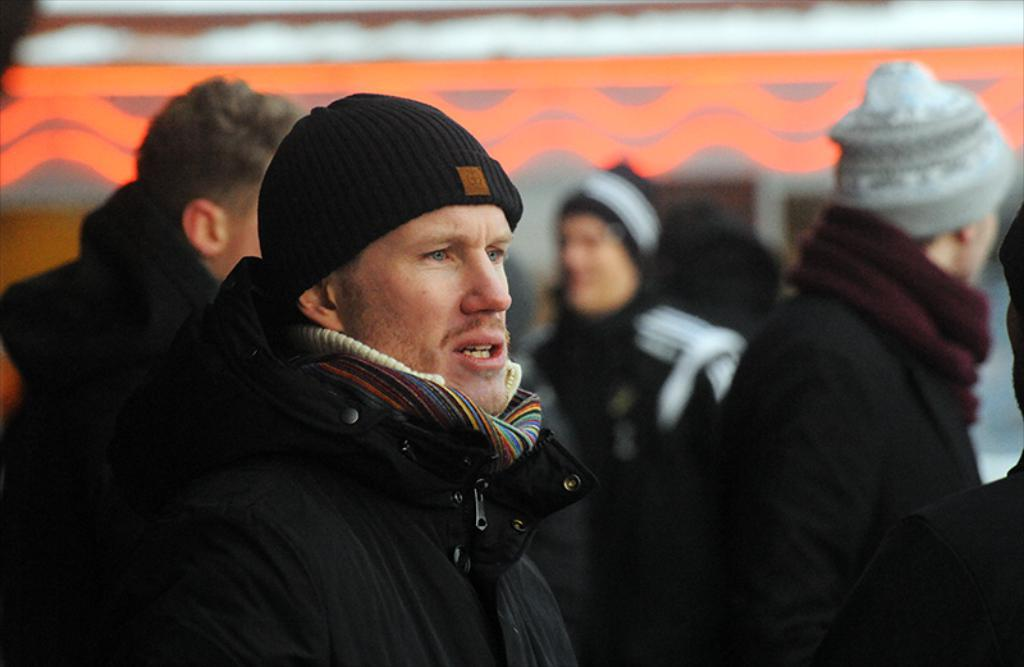What is the main subject of the image? The main subject of the image is a man in the middle. What is the man in the middle wearing? The man in the middle is wearing a jacket and a cap. Are there any other people in the image? Yes, there is another man on the right side of the image, and many people in the background. What can be seen in the background of the image? There is at least one building in the background of the image. What type of advice can be seen being given in the image? There is no advice being given in the image; it features two men wearing jackets and caps, with many people and a building in the background. 